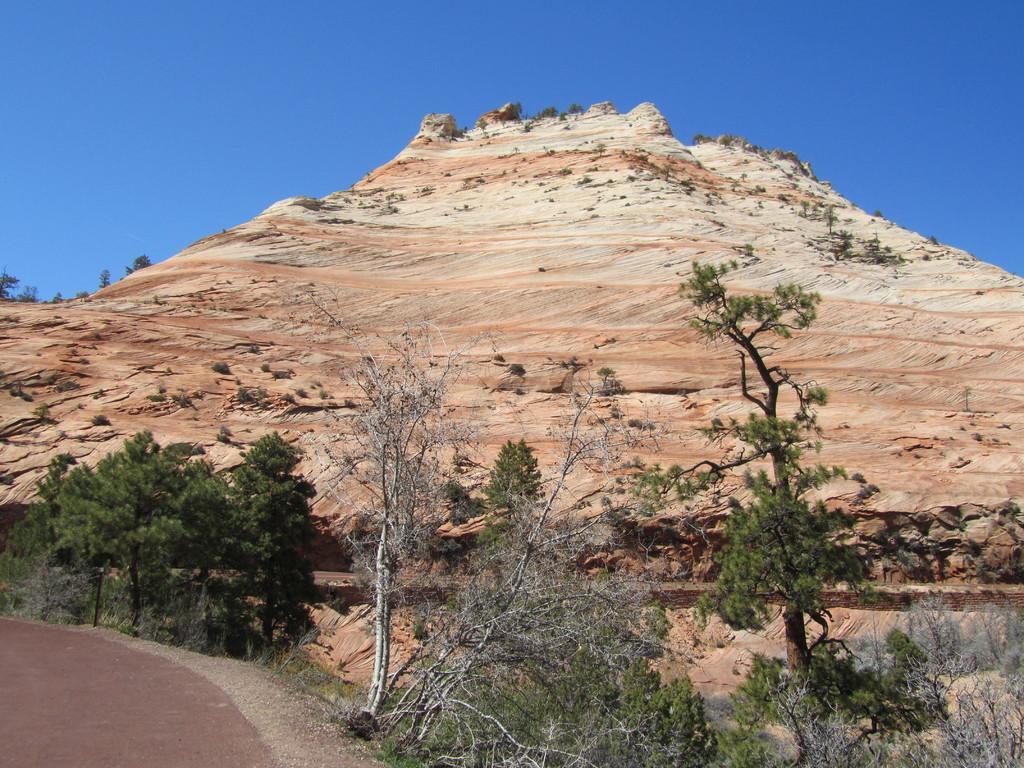Describe this image in one or two sentences. This picture is clicked outside. In the foreground we can see the plants and the ground. In the background we can see the sky, hill and some other items. 